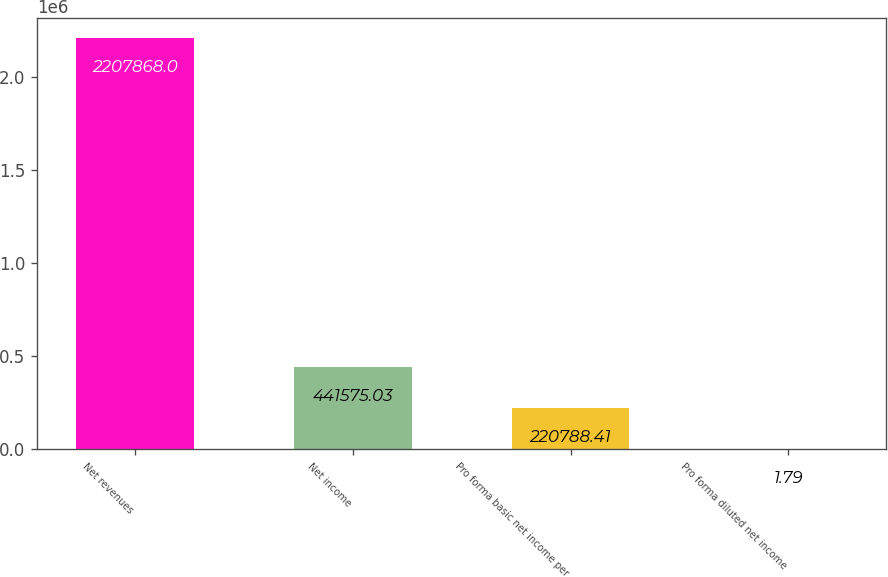Convert chart. <chart><loc_0><loc_0><loc_500><loc_500><bar_chart><fcel>Net revenues<fcel>Net income<fcel>Pro forma basic net income per<fcel>Pro forma diluted net income<nl><fcel>2.20787e+06<fcel>441575<fcel>220788<fcel>1.79<nl></chart> 